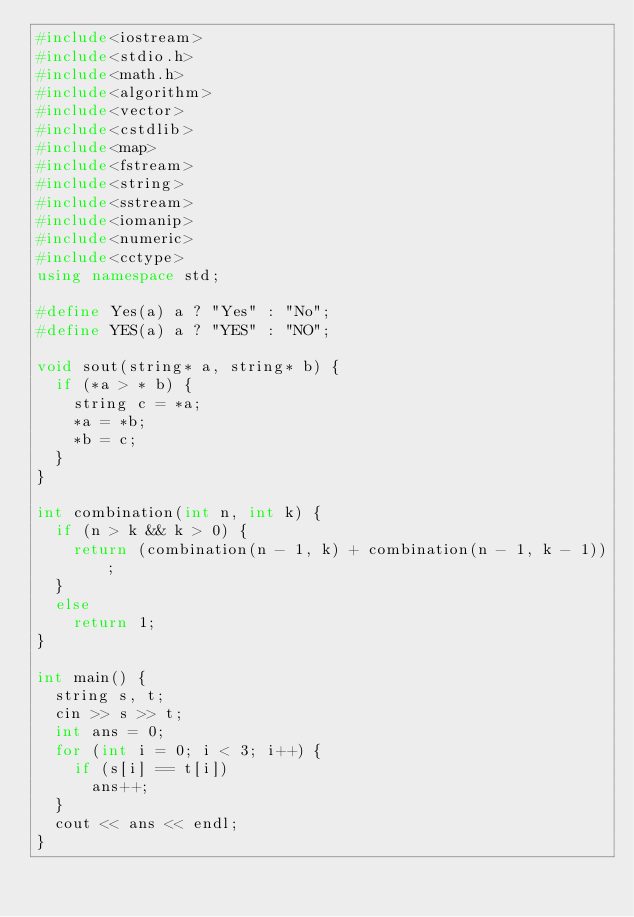Convert code to text. <code><loc_0><loc_0><loc_500><loc_500><_C++_>#include<iostream>
#include<stdio.h>
#include<math.h>
#include<algorithm>
#include<vector>
#include<cstdlib>
#include<map>
#include<fstream>
#include<string>
#include<sstream>
#include<iomanip>
#include<numeric>
#include<cctype>
using namespace std;

#define Yes(a) a ? "Yes" : "No";
#define YES(a) a ? "YES" : "NO";

void sout(string* a, string* b) {
	if (*a > * b) {
		string c = *a;
		*a = *b;
		*b = c;
	}
}

int combination(int n, int k) {
	if (n > k && k > 0) {
		return (combination(n - 1, k) + combination(n - 1, k - 1));
	}
	else
		return 1;
}

int main() {
	string s, t;
	cin >> s >> t;
	int ans = 0;
	for (int i = 0; i < 3; i++) {
		if (s[i] == t[i])
			ans++;
	}
	cout << ans << endl;
}
</code> 